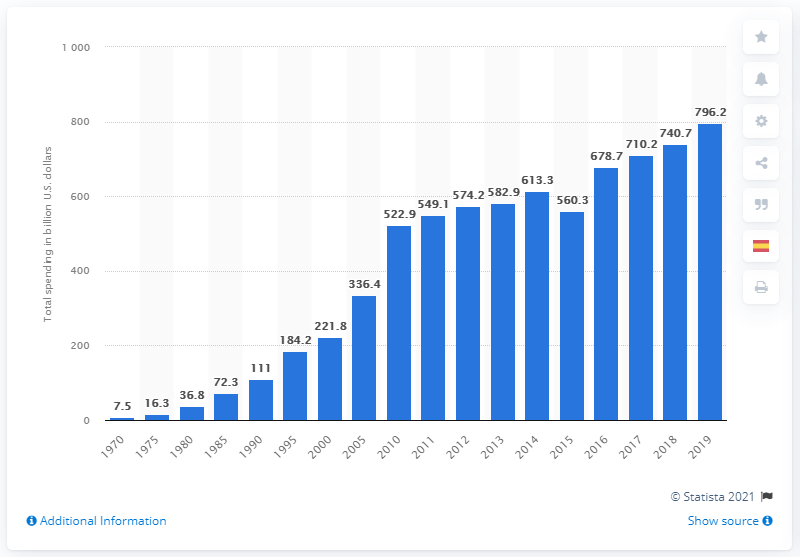Outline some significant characteristics in this image. In 2019, spending on Medicare came to an end. In the United States, a total of 796.2 billion dollars was spent on Medicare from 1970 to 2019. In 1970, the amount of money spent on Medicare was approximately 7.5... 